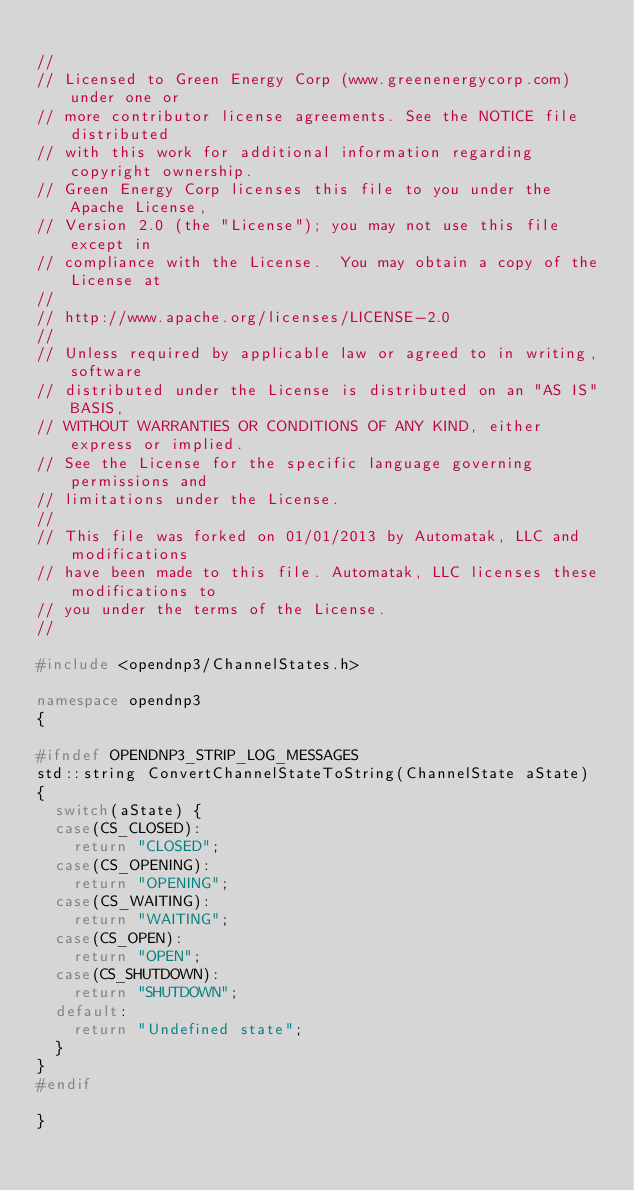Convert code to text. <code><loc_0><loc_0><loc_500><loc_500><_C++_>
//
// Licensed to Green Energy Corp (www.greenenergycorp.com) under one or
// more contributor license agreements. See the NOTICE file distributed
// with this work for additional information regarding copyright ownership.
// Green Energy Corp licenses this file to you under the Apache License,
// Version 2.0 (the "License"); you may not use this file except in
// compliance with the License.  You may obtain a copy of the License at
//
// http://www.apache.org/licenses/LICENSE-2.0
//
// Unless required by applicable law or agreed to in writing, software
// distributed under the License is distributed on an "AS IS" BASIS,
// WITHOUT WARRANTIES OR CONDITIONS OF ANY KIND, either express or implied.
// See the License for the specific language governing permissions and
// limitations under the License.
//
// This file was forked on 01/01/2013 by Automatak, LLC and modifications
// have been made to this file. Automatak, LLC licenses these modifications to
// you under the terms of the License.
//

#include <opendnp3/ChannelStates.h>

namespace opendnp3
{

#ifndef OPENDNP3_STRIP_LOG_MESSAGES
std::string ConvertChannelStateToString(ChannelState aState)
{
	switch(aState) {
	case(CS_CLOSED):
		return "CLOSED";
	case(CS_OPENING):
		return "OPENING";
	case(CS_WAITING):
		return "WAITING";
	case(CS_OPEN):
		return "OPEN";
	case(CS_SHUTDOWN):
		return "SHUTDOWN";
	default:
		return "Undefined state";
	}
}
#endif

}


</code> 